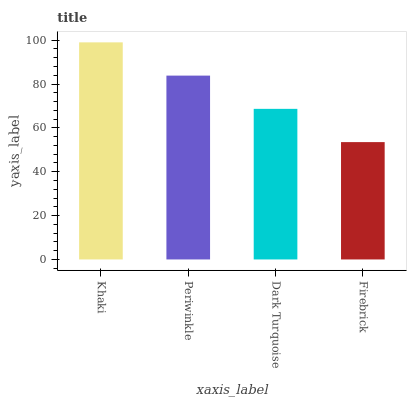Is Periwinkle the minimum?
Answer yes or no. No. Is Periwinkle the maximum?
Answer yes or no. No. Is Khaki greater than Periwinkle?
Answer yes or no. Yes. Is Periwinkle less than Khaki?
Answer yes or no. Yes. Is Periwinkle greater than Khaki?
Answer yes or no. No. Is Khaki less than Periwinkle?
Answer yes or no. No. Is Periwinkle the high median?
Answer yes or no. Yes. Is Dark Turquoise the low median?
Answer yes or no. Yes. Is Khaki the high median?
Answer yes or no. No. Is Periwinkle the low median?
Answer yes or no. No. 